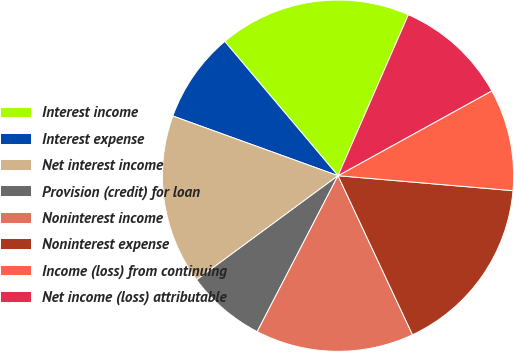<chart> <loc_0><loc_0><loc_500><loc_500><pie_chart><fcel>Interest income<fcel>Interest expense<fcel>Net interest income<fcel>Provision (credit) for loan<fcel>Noninterest income<fcel>Noninterest expense<fcel>Income (loss) from continuing<fcel>Net income (loss) attributable<nl><fcel>17.71%<fcel>8.33%<fcel>15.62%<fcel>7.29%<fcel>14.58%<fcel>16.67%<fcel>9.38%<fcel>10.42%<nl></chart> 